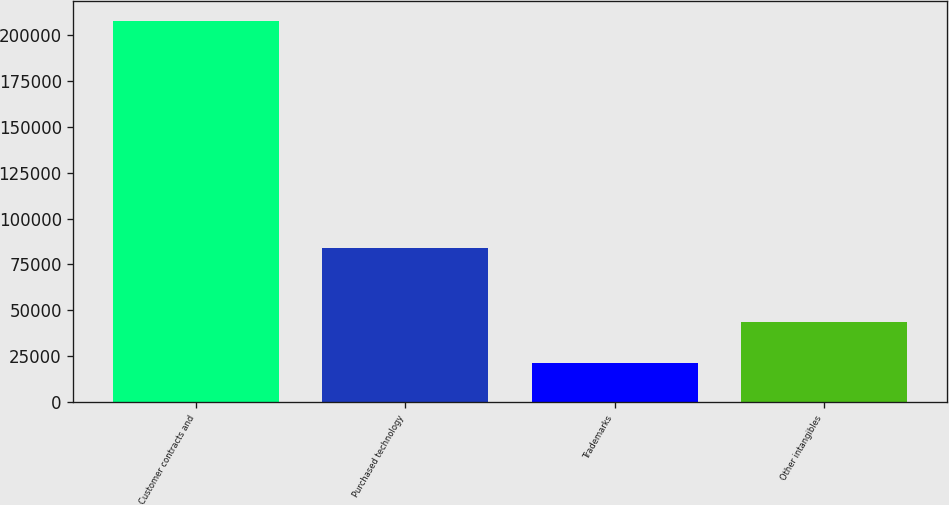Convert chart. <chart><loc_0><loc_0><loc_500><loc_500><bar_chart><fcel>Customer contracts and<fcel>Purchased technology<fcel>Trademarks<fcel>Other intangibles<nl><fcel>208000<fcel>84200<fcel>21100<fcel>43400<nl></chart> 